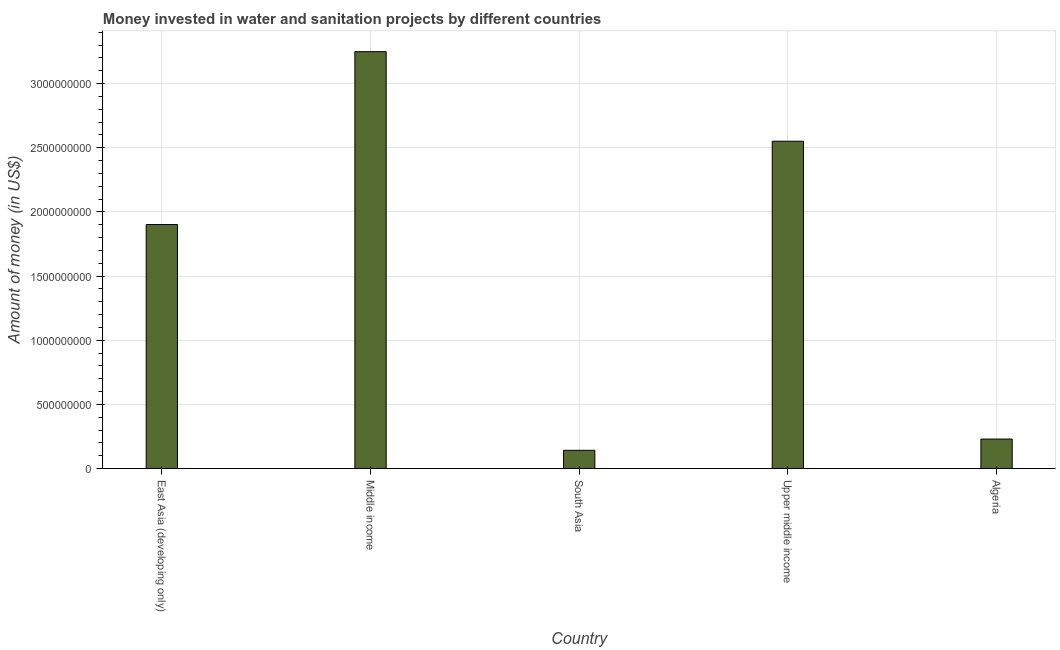Does the graph contain any zero values?
Give a very brief answer. No. Does the graph contain grids?
Offer a very short reply. Yes. What is the title of the graph?
Make the answer very short. Money invested in water and sanitation projects by different countries. What is the label or title of the X-axis?
Your response must be concise. Country. What is the label or title of the Y-axis?
Give a very brief answer. Amount of money (in US$). What is the investment in South Asia?
Make the answer very short. 1.42e+08. Across all countries, what is the maximum investment?
Offer a terse response. 3.25e+09. Across all countries, what is the minimum investment?
Provide a short and direct response. 1.42e+08. What is the sum of the investment?
Offer a terse response. 8.07e+09. What is the difference between the investment in Middle income and Upper middle income?
Ensure brevity in your answer.  6.98e+08. What is the average investment per country?
Give a very brief answer. 1.61e+09. What is the median investment?
Give a very brief answer. 1.90e+09. What is the ratio of the investment in Algeria to that in East Asia (developing only)?
Your response must be concise. 0.12. Is the investment in Algeria less than that in East Asia (developing only)?
Make the answer very short. Yes. Is the difference between the investment in Algeria and Upper middle income greater than the difference between any two countries?
Your response must be concise. No. What is the difference between the highest and the second highest investment?
Provide a succinct answer. 6.98e+08. Is the sum of the investment in East Asia (developing only) and South Asia greater than the maximum investment across all countries?
Keep it short and to the point. No. What is the difference between the highest and the lowest investment?
Make the answer very short. 3.11e+09. Are all the bars in the graph horizontal?
Your answer should be compact. No. How many countries are there in the graph?
Ensure brevity in your answer.  5. What is the difference between two consecutive major ticks on the Y-axis?
Offer a very short reply. 5.00e+08. What is the Amount of money (in US$) in East Asia (developing only)?
Provide a succinct answer. 1.90e+09. What is the Amount of money (in US$) of Middle income?
Your response must be concise. 3.25e+09. What is the Amount of money (in US$) in South Asia?
Make the answer very short. 1.42e+08. What is the Amount of money (in US$) of Upper middle income?
Ensure brevity in your answer.  2.55e+09. What is the Amount of money (in US$) of Algeria?
Your response must be concise. 2.30e+08. What is the difference between the Amount of money (in US$) in East Asia (developing only) and Middle income?
Give a very brief answer. -1.35e+09. What is the difference between the Amount of money (in US$) in East Asia (developing only) and South Asia?
Offer a terse response. 1.76e+09. What is the difference between the Amount of money (in US$) in East Asia (developing only) and Upper middle income?
Make the answer very short. -6.49e+08. What is the difference between the Amount of money (in US$) in East Asia (developing only) and Algeria?
Your response must be concise. 1.67e+09. What is the difference between the Amount of money (in US$) in Middle income and South Asia?
Offer a very short reply. 3.11e+09. What is the difference between the Amount of money (in US$) in Middle income and Upper middle income?
Ensure brevity in your answer.  6.98e+08. What is the difference between the Amount of money (in US$) in Middle income and Algeria?
Your answer should be very brief. 3.02e+09. What is the difference between the Amount of money (in US$) in South Asia and Upper middle income?
Offer a terse response. -2.41e+09. What is the difference between the Amount of money (in US$) in South Asia and Algeria?
Provide a short and direct response. -8.78e+07. What is the difference between the Amount of money (in US$) in Upper middle income and Algeria?
Give a very brief answer. 2.32e+09. What is the ratio of the Amount of money (in US$) in East Asia (developing only) to that in Middle income?
Provide a short and direct response. 0.58. What is the ratio of the Amount of money (in US$) in East Asia (developing only) to that in South Asia?
Offer a very short reply. 13.37. What is the ratio of the Amount of money (in US$) in East Asia (developing only) to that in Upper middle income?
Make the answer very short. 0.74. What is the ratio of the Amount of money (in US$) in East Asia (developing only) to that in Algeria?
Provide a succinct answer. 8.27. What is the ratio of the Amount of money (in US$) in Middle income to that in South Asia?
Ensure brevity in your answer.  22.84. What is the ratio of the Amount of money (in US$) in Middle income to that in Upper middle income?
Provide a short and direct response. 1.27. What is the ratio of the Amount of money (in US$) in Middle income to that in Algeria?
Your response must be concise. 14.13. What is the ratio of the Amount of money (in US$) in South Asia to that in Upper middle income?
Your answer should be very brief. 0.06. What is the ratio of the Amount of money (in US$) in South Asia to that in Algeria?
Offer a terse response. 0.62. What is the ratio of the Amount of money (in US$) in Upper middle income to that in Algeria?
Offer a very short reply. 11.09. 